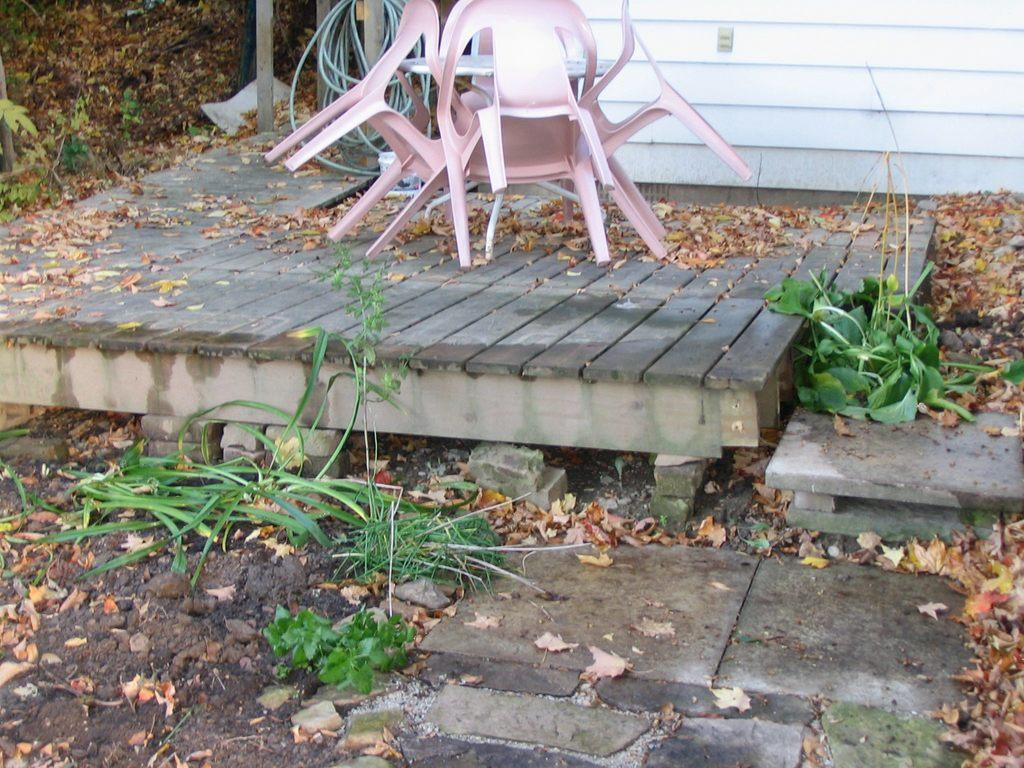What type of furniture is present in the image? There is a table and chairs in the image. What type of surface is visible at the bottom of the image? Grass is visible at the bottom of the image. What type of material is present in the image? Shredded leaves are present in the image. What type of outdoor structure is visible in the image? There is a wooden deck in the image. What type of architectural feature is visible in the background of the image? There is a wall in the background of the image. How many dolls are sitting on the wooden deck in the image? There are no dolls present in the image. What type of gardening tool is leaning against the wall in the background of the image? There is no gardening tool present in the image. 